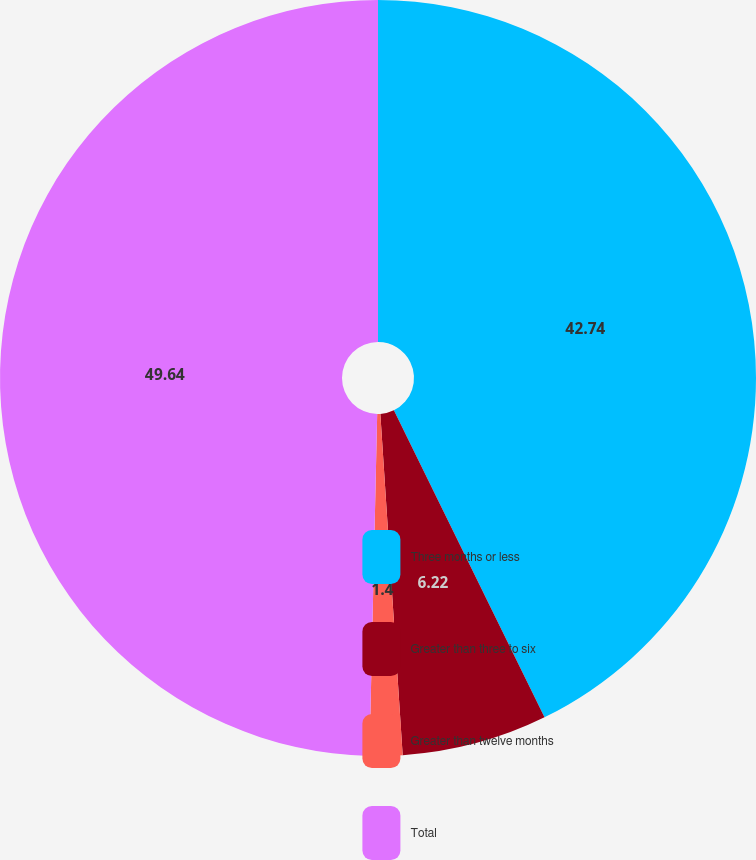Convert chart. <chart><loc_0><loc_0><loc_500><loc_500><pie_chart><fcel>Three months or less<fcel>Greater than three to six<fcel>Greater than twelve months<fcel>Total<nl><fcel>42.74%<fcel>6.22%<fcel>1.4%<fcel>49.64%<nl></chart> 